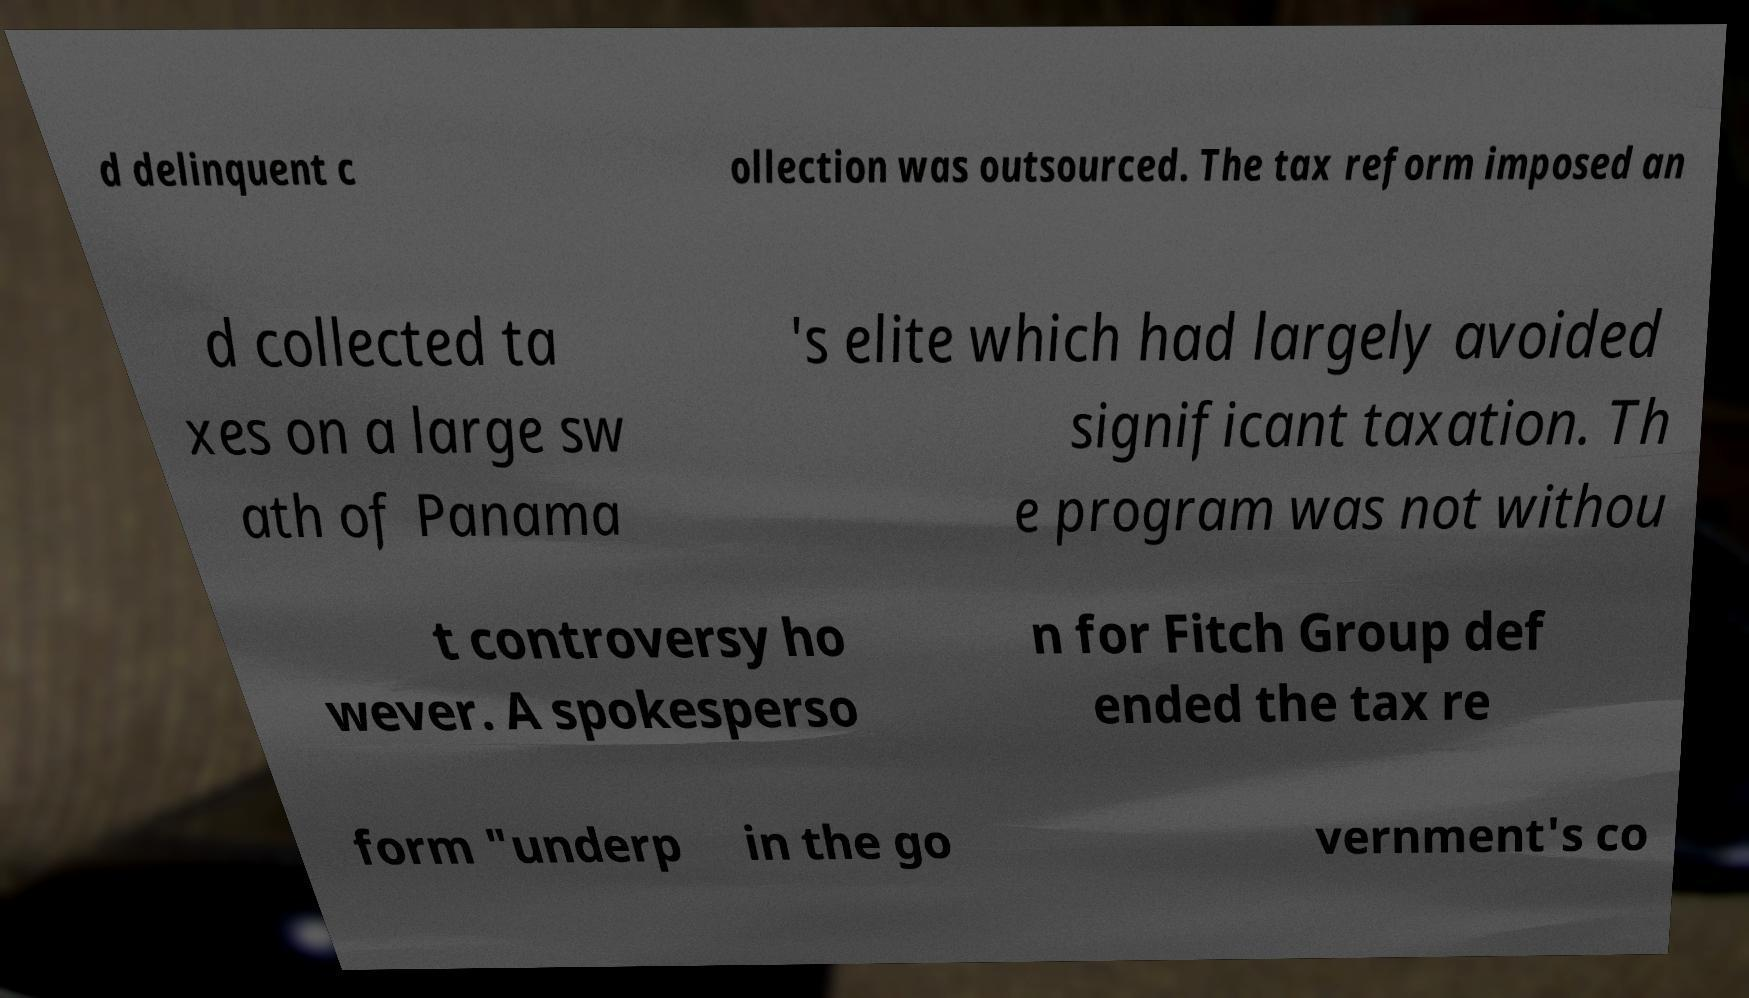Can you read and provide the text displayed in the image?This photo seems to have some interesting text. Can you extract and type it out for me? d delinquent c ollection was outsourced. The tax reform imposed an d collected ta xes on a large sw ath of Panama 's elite which had largely avoided significant taxation. Th e program was not withou t controversy ho wever. A spokesperso n for Fitch Group def ended the tax re form "underp in the go vernment's co 